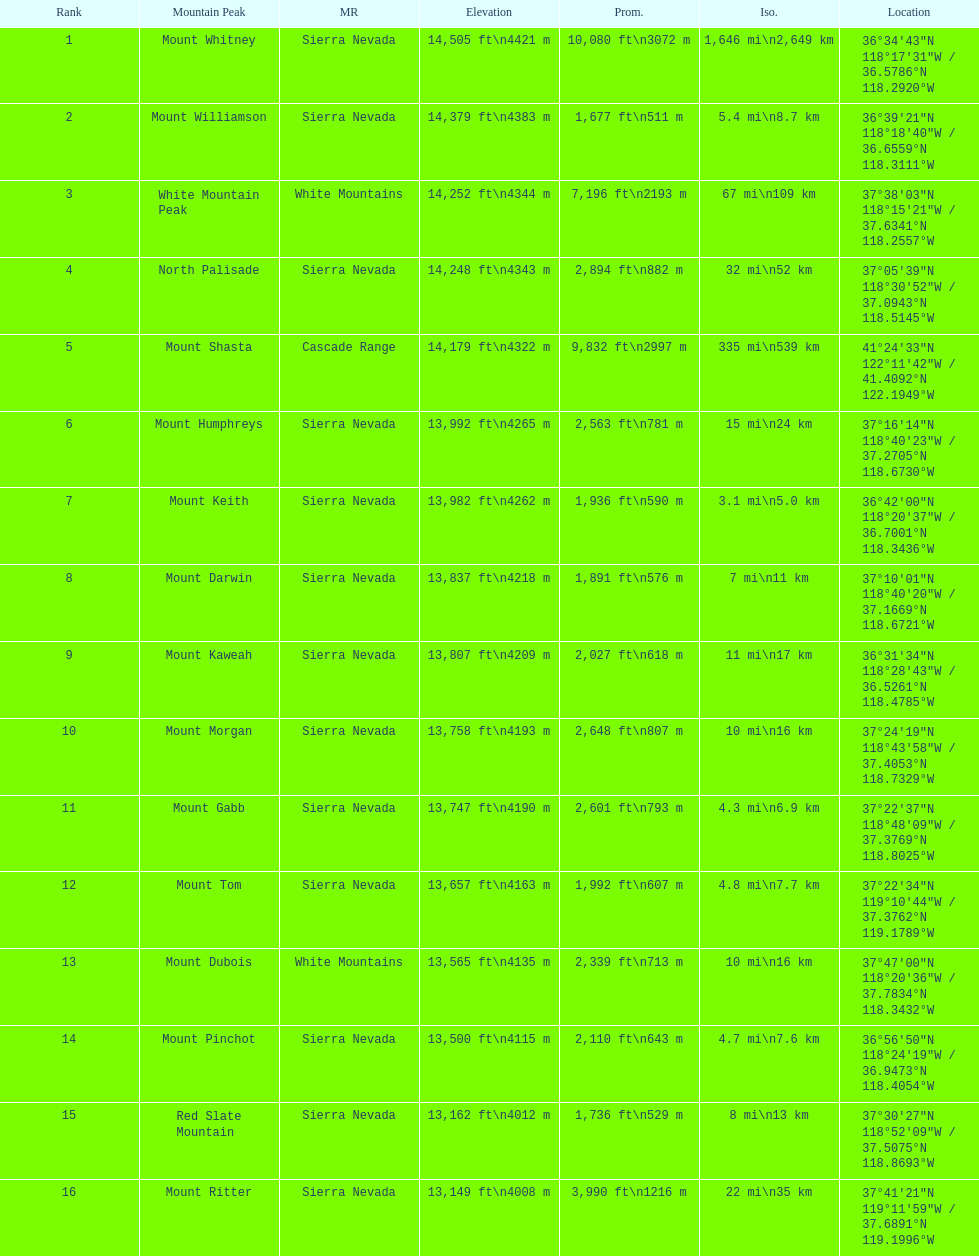Could you parse the entire table? {'header': ['Rank', 'Mountain Peak', 'MR', 'Elevation', 'Prom.', 'Iso.', 'Location'], 'rows': [['1', 'Mount Whitney', 'Sierra Nevada', '14,505\xa0ft\\n4421\xa0m', '10,080\xa0ft\\n3072\xa0m', '1,646\xa0mi\\n2,649\xa0km', '36°34′43″N 118°17′31″W\ufeff / \ufeff36.5786°N 118.2920°W'], ['2', 'Mount Williamson', 'Sierra Nevada', '14,379\xa0ft\\n4383\xa0m', '1,677\xa0ft\\n511\xa0m', '5.4\xa0mi\\n8.7\xa0km', '36°39′21″N 118°18′40″W\ufeff / \ufeff36.6559°N 118.3111°W'], ['3', 'White Mountain Peak', 'White Mountains', '14,252\xa0ft\\n4344\xa0m', '7,196\xa0ft\\n2193\xa0m', '67\xa0mi\\n109\xa0km', '37°38′03″N 118°15′21″W\ufeff / \ufeff37.6341°N 118.2557°W'], ['4', 'North Palisade', 'Sierra Nevada', '14,248\xa0ft\\n4343\xa0m', '2,894\xa0ft\\n882\xa0m', '32\xa0mi\\n52\xa0km', '37°05′39″N 118°30′52″W\ufeff / \ufeff37.0943°N 118.5145°W'], ['5', 'Mount Shasta', 'Cascade Range', '14,179\xa0ft\\n4322\xa0m', '9,832\xa0ft\\n2997\xa0m', '335\xa0mi\\n539\xa0km', '41°24′33″N 122°11′42″W\ufeff / \ufeff41.4092°N 122.1949°W'], ['6', 'Mount Humphreys', 'Sierra Nevada', '13,992\xa0ft\\n4265\xa0m', '2,563\xa0ft\\n781\xa0m', '15\xa0mi\\n24\xa0km', '37°16′14″N 118°40′23″W\ufeff / \ufeff37.2705°N 118.6730°W'], ['7', 'Mount Keith', 'Sierra Nevada', '13,982\xa0ft\\n4262\xa0m', '1,936\xa0ft\\n590\xa0m', '3.1\xa0mi\\n5.0\xa0km', '36°42′00″N 118°20′37″W\ufeff / \ufeff36.7001°N 118.3436°W'], ['8', 'Mount Darwin', 'Sierra Nevada', '13,837\xa0ft\\n4218\xa0m', '1,891\xa0ft\\n576\xa0m', '7\xa0mi\\n11\xa0km', '37°10′01″N 118°40′20″W\ufeff / \ufeff37.1669°N 118.6721°W'], ['9', 'Mount Kaweah', 'Sierra Nevada', '13,807\xa0ft\\n4209\xa0m', '2,027\xa0ft\\n618\xa0m', '11\xa0mi\\n17\xa0km', '36°31′34″N 118°28′43″W\ufeff / \ufeff36.5261°N 118.4785°W'], ['10', 'Mount Morgan', 'Sierra Nevada', '13,758\xa0ft\\n4193\xa0m', '2,648\xa0ft\\n807\xa0m', '10\xa0mi\\n16\xa0km', '37°24′19″N 118°43′58″W\ufeff / \ufeff37.4053°N 118.7329°W'], ['11', 'Mount Gabb', 'Sierra Nevada', '13,747\xa0ft\\n4190\xa0m', '2,601\xa0ft\\n793\xa0m', '4.3\xa0mi\\n6.9\xa0km', '37°22′37″N 118°48′09″W\ufeff / \ufeff37.3769°N 118.8025°W'], ['12', 'Mount Tom', 'Sierra Nevada', '13,657\xa0ft\\n4163\xa0m', '1,992\xa0ft\\n607\xa0m', '4.8\xa0mi\\n7.7\xa0km', '37°22′34″N 119°10′44″W\ufeff / \ufeff37.3762°N 119.1789°W'], ['13', 'Mount Dubois', 'White Mountains', '13,565\xa0ft\\n4135\xa0m', '2,339\xa0ft\\n713\xa0m', '10\xa0mi\\n16\xa0km', '37°47′00″N 118°20′36″W\ufeff / \ufeff37.7834°N 118.3432°W'], ['14', 'Mount Pinchot', 'Sierra Nevada', '13,500\xa0ft\\n4115\xa0m', '2,110\xa0ft\\n643\xa0m', '4.7\xa0mi\\n7.6\xa0km', '36°56′50″N 118°24′19″W\ufeff / \ufeff36.9473°N 118.4054°W'], ['15', 'Red Slate Mountain', 'Sierra Nevada', '13,162\xa0ft\\n4012\xa0m', '1,736\xa0ft\\n529\xa0m', '8\xa0mi\\n13\xa0km', '37°30′27″N 118°52′09″W\ufeff / \ufeff37.5075°N 118.8693°W'], ['16', 'Mount Ritter', 'Sierra Nevada', '13,149\xa0ft\\n4008\xa0m', '3,990\xa0ft\\n1216\xa0m', '22\xa0mi\\n35\xa0km', '37°41′21″N 119°11′59″W\ufeff / \ufeff37.6891°N 119.1996°W']]} Which mountain peak is the only mountain peak in the cascade range? Mount Shasta. 